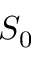Convert formula to latex. <formula><loc_0><loc_0><loc_500><loc_500>S _ { 0 }</formula> 